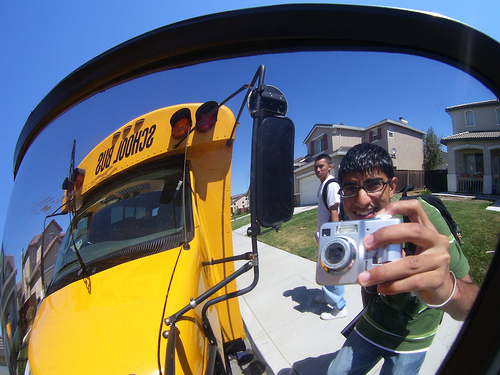Please provide a short description for this region: [0.6, 0.42, 0.92, 0.84]. This region captures a student holding a camera, with a cheerful expression on his face. 